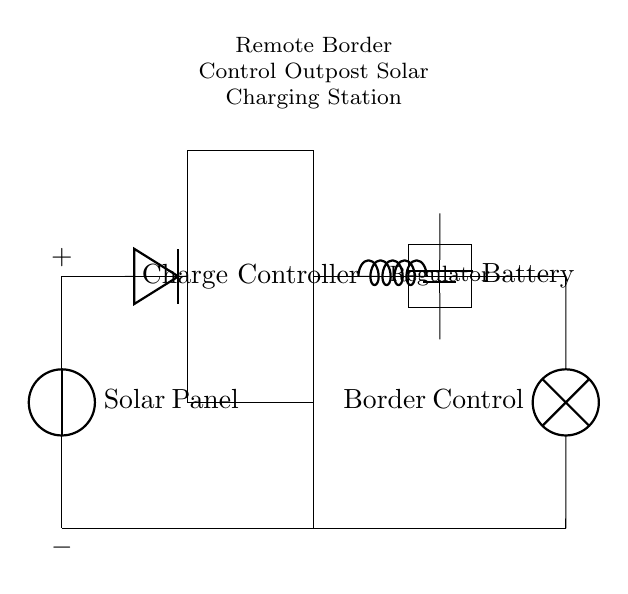What type of energy source powers this charging station? The solar panel is the main component that converts sunlight into electrical energy to power the charging station.
Answer: Solar energy What component regulates the voltage supplied to the load? The regulator is placed in the circuit to manage and maintain the output voltage level suitable for the border control equipment, ensuring it operates correctly.
Answer: Regulator What is the purpose of the diode in the circuit? The diode prevents reverse current flow from the battery back to the solar panel, ensuring that the solar panel charges the battery and not the other way around.
Answer: Reverse current protection How many main components are there in this circuit? The circuit includes four main components: solar panel, charge controller, battery, and load (border control). A proper count of the labeled components leads to this conclusion.
Answer: Four What happens to excess solar energy when the battery is fully charged? When the battery reaches full charge, the charge controller typically either stops the incoming current or diverts excess energy to avoid battery damage. This indicates how charging systems work effectively without overcharging.
Answer: Stops incoming current What is the load connected to the charging station? The load in this circuit is represented by the border control equipment, which requires power to operate while stationed at a remote location.
Answer: Border control 